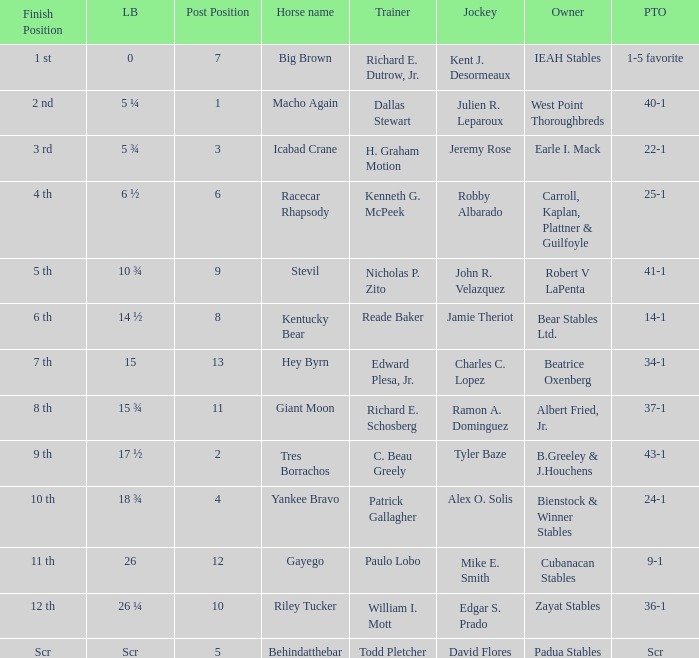Which jockey had a post time odds of 34-1? Charles C. Lopez. 